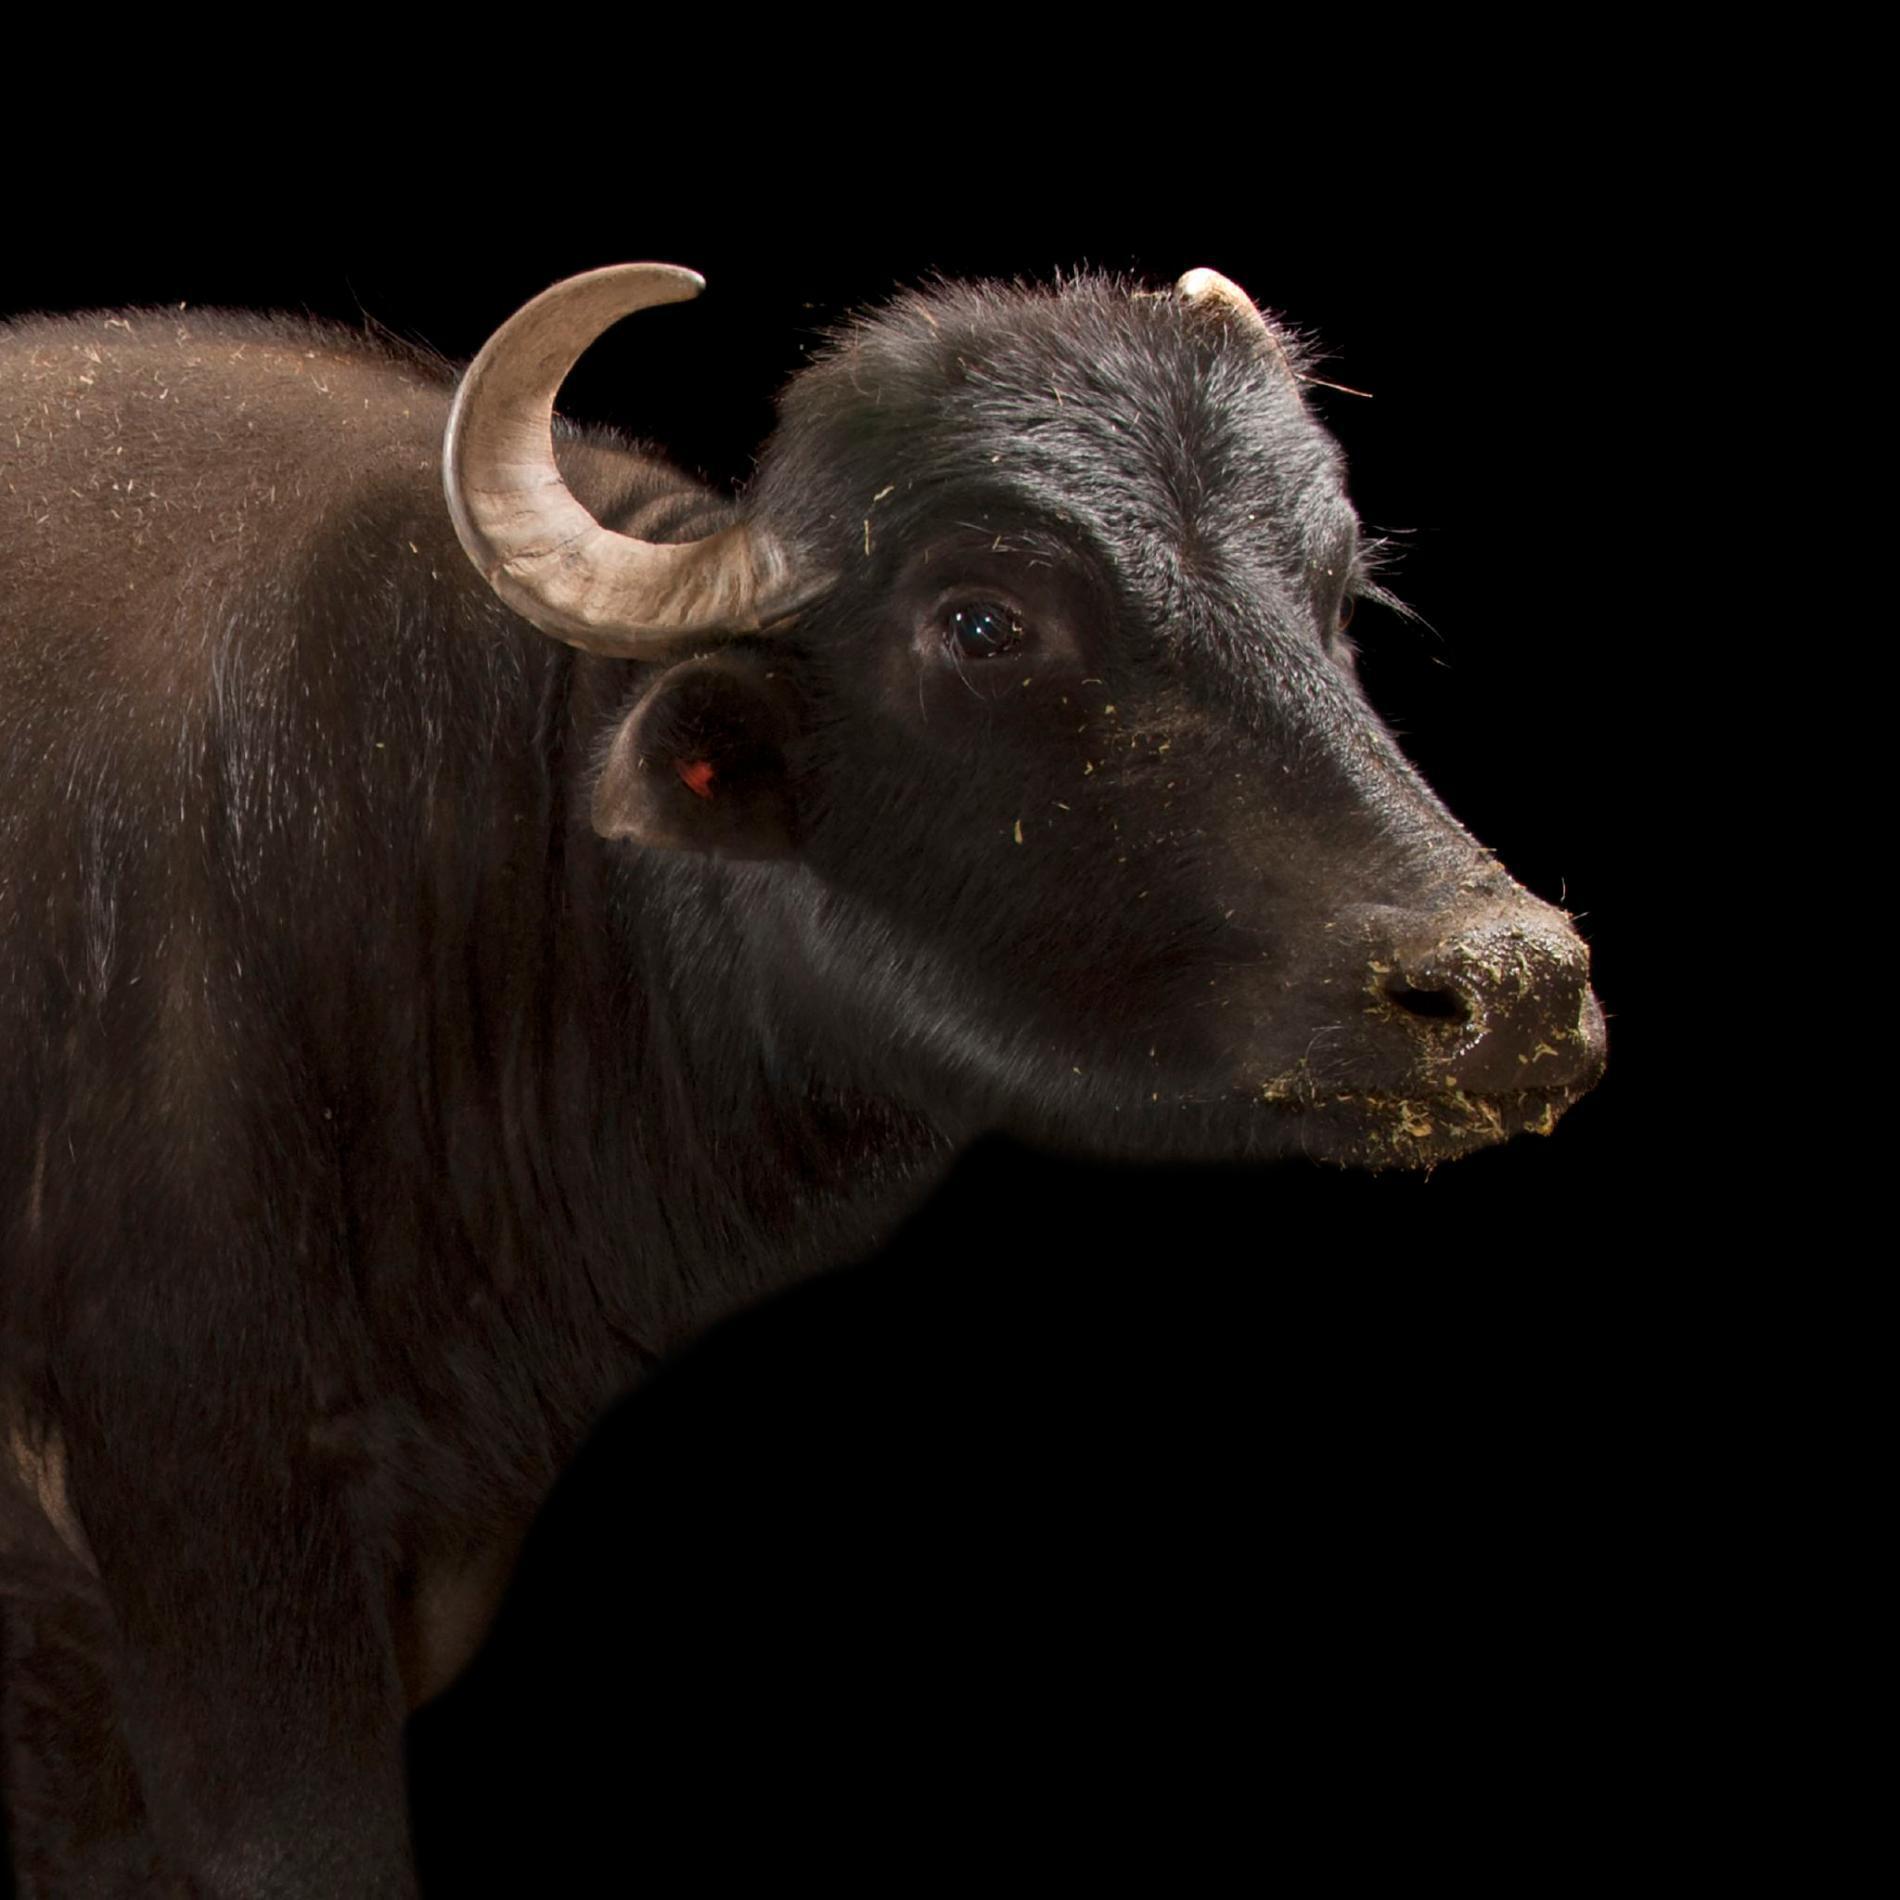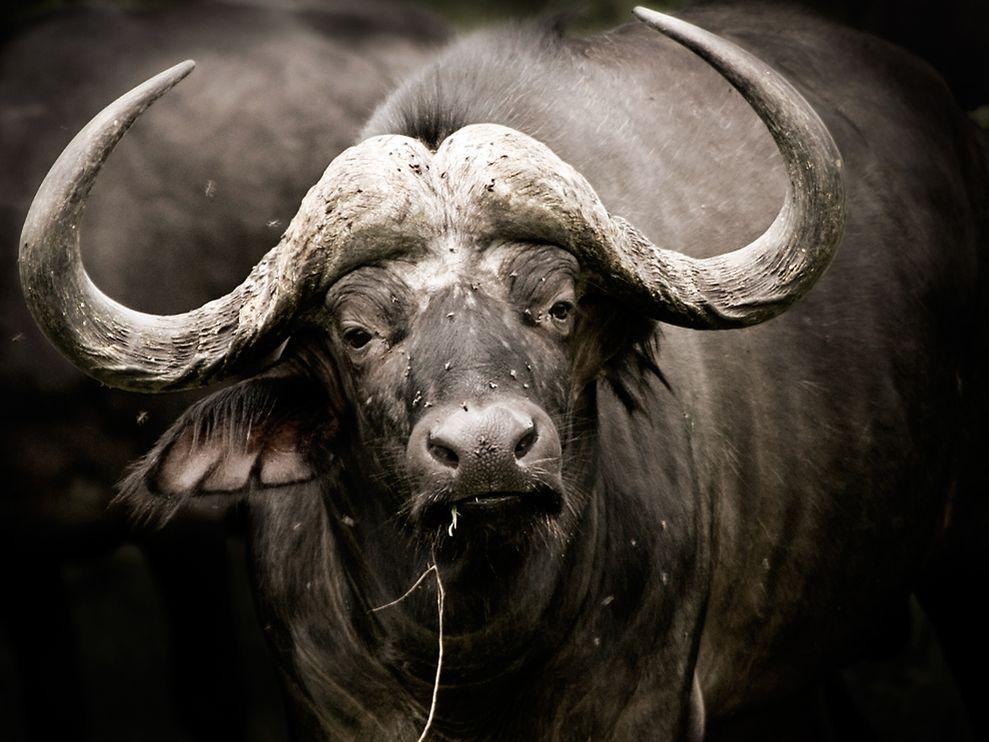The first image is the image on the left, the second image is the image on the right. Evaluate the accuracy of this statement regarding the images: "An image features a camera-facing water buffalo with a bird perched on it.". Is it true? Answer yes or no. No. The first image is the image on the left, the second image is the image on the right. For the images shown, is this caption "Each image contains one water buffalo in the foreground who is looking directly ahead at the camera." true? Answer yes or no. No. The first image is the image on the left, the second image is the image on the right. Considering the images on both sides, is "At least one bird is landing or on a water buffalo." valid? Answer yes or no. No. 